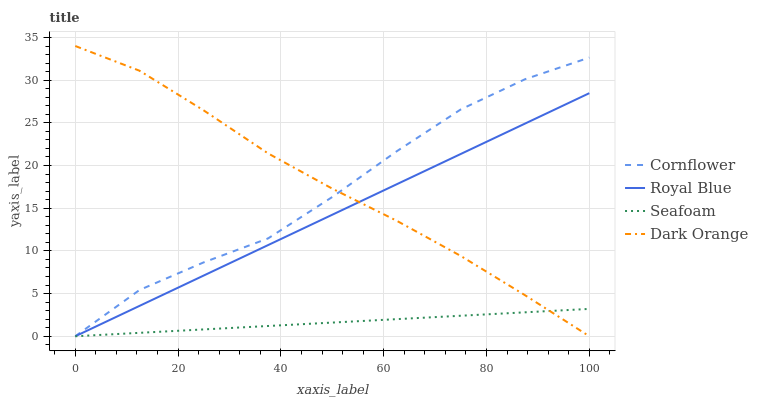Does Seafoam have the minimum area under the curve?
Answer yes or no. Yes. Does Dark Orange have the maximum area under the curve?
Answer yes or no. Yes. Does Cornflower have the minimum area under the curve?
Answer yes or no. No. Does Cornflower have the maximum area under the curve?
Answer yes or no. No. Is Seafoam the smoothest?
Answer yes or no. Yes. Is Cornflower the roughest?
Answer yes or no. Yes. Is Cornflower the smoothest?
Answer yes or no. No. Is Seafoam the roughest?
Answer yes or no. No. Does Dark Orange have the lowest value?
Answer yes or no. Yes. Does Dark Orange have the highest value?
Answer yes or no. Yes. Does Cornflower have the highest value?
Answer yes or no. No. Does Cornflower intersect Dark Orange?
Answer yes or no. Yes. Is Cornflower less than Dark Orange?
Answer yes or no. No. Is Cornflower greater than Dark Orange?
Answer yes or no. No. 